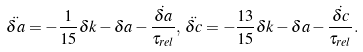Convert formula to latex. <formula><loc_0><loc_0><loc_500><loc_500>\ddot { \delta a } = - \frac { 1 } { 1 5 } \delta k - \delta a - \frac { \dot { \delta a } } { \tau _ { r e l } } , \, \ddot { \delta c } = - \frac { 1 3 } { 1 5 } \delta k - \delta a - \frac { \dot { \delta c } } { \tau _ { r e l } } .</formula> 